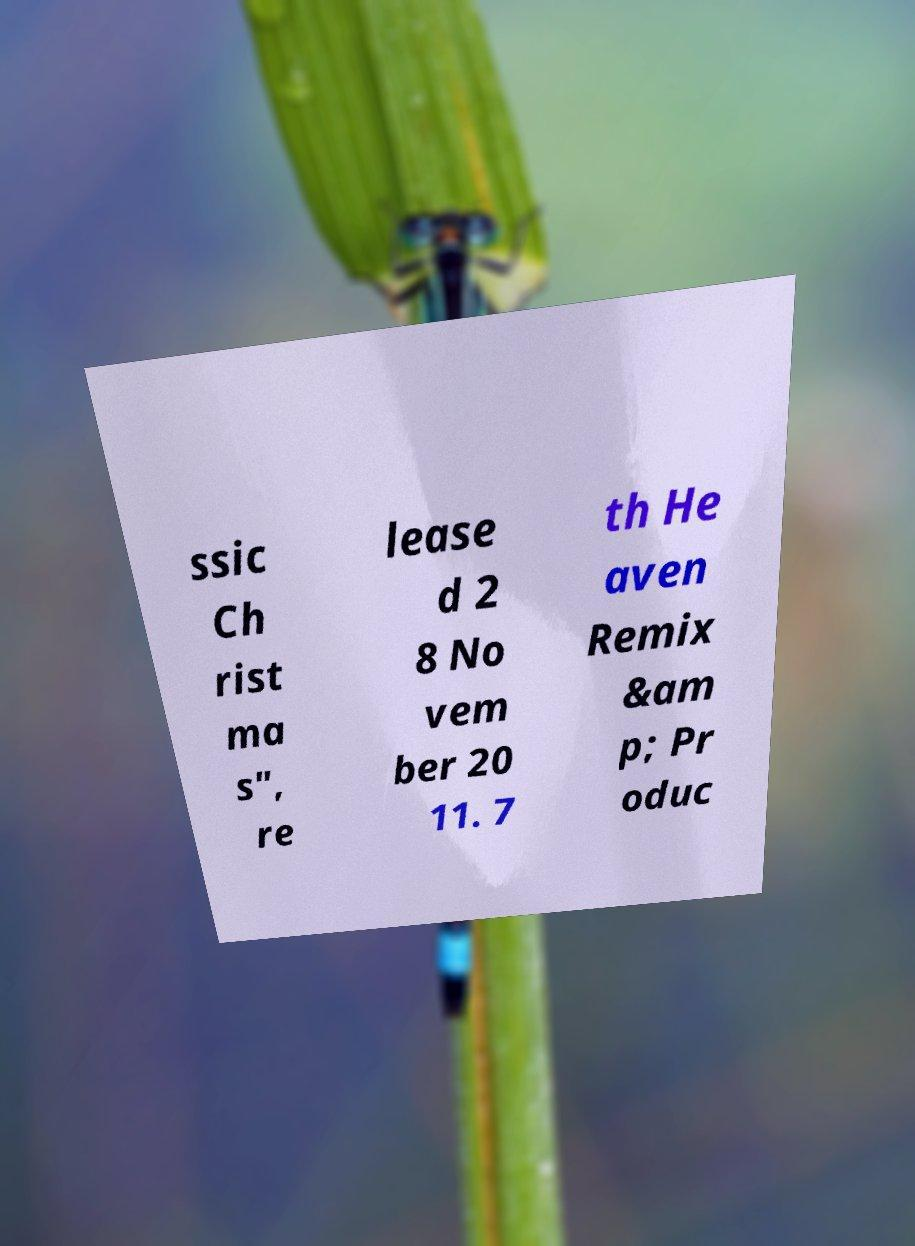Could you extract and type out the text from this image? ssic Ch rist ma s", re lease d 2 8 No vem ber 20 11. 7 th He aven Remix &am p; Pr oduc 